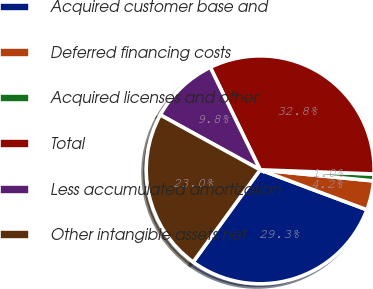Convert chart to OTSL. <chart><loc_0><loc_0><loc_500><loc_500><pie_chart><fcel>Acquired customer base and<fcel>Deferred financing costs<fcel>Acquired licenses and other<fcel>Total<fcel>Less accumulated amortization<fcel>Other intangible assets net<nl><fcel>29.3%<fcel>4.15%<fcel>0.97%<fcel>32.79%<fcel>9.79%<fcel>22.99%<nl></chart> 